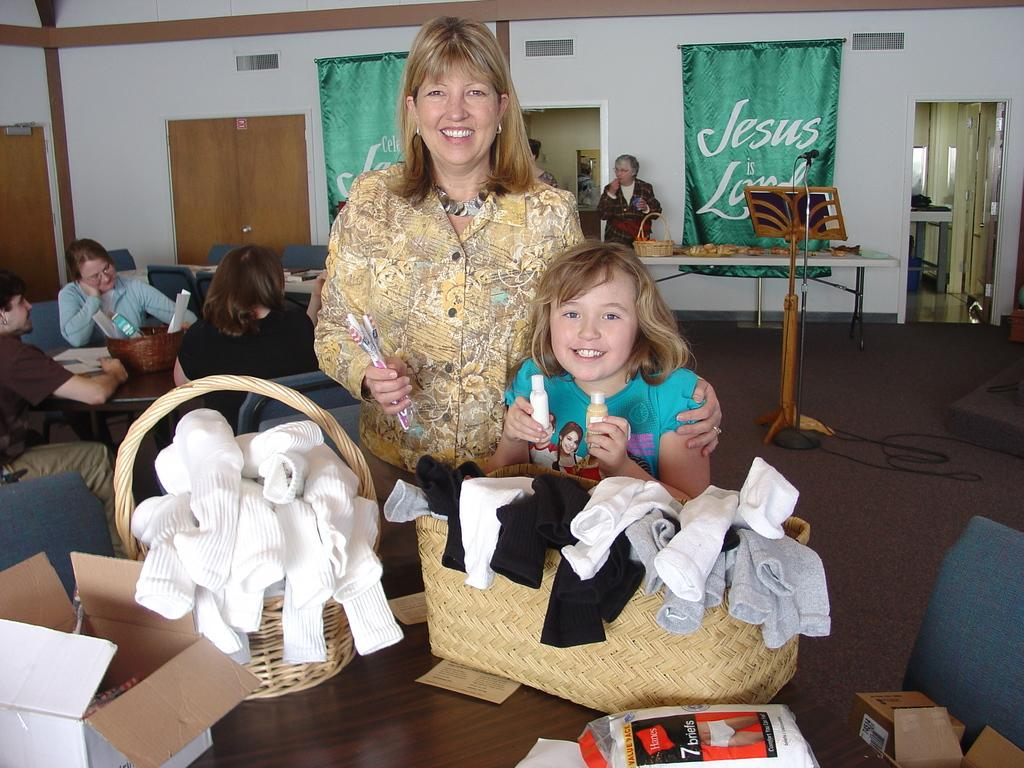How many people are present in the image? There are many persons in the image. What is located in front of the persons? There is a table in front of the persons. Can you describe the interaction between a person and a child in the image? There is a person standing with a small kid beside her. What can be seen on the wall in the image? There is a banner on the wall in the image. What type of caption is written on the banner in the image? There is no caption visible on the banner in the image. How does the stocking affect the stomach of the person standing with the small kid? There is no mention of stockings or stomachs in the image, so it is not possible to answer that question. 